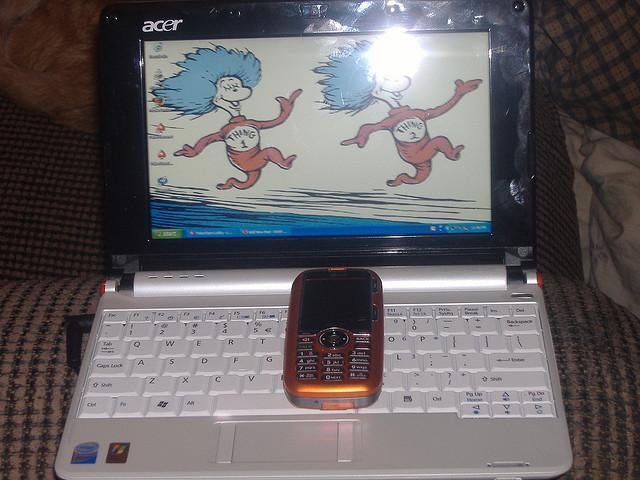How many cell phones are in the picture?
Give a very brief answer. 1. How many laptops can you see?
Give a very brief answer. 1. How many cars are to the right?
Give a very brief answer. 0. 